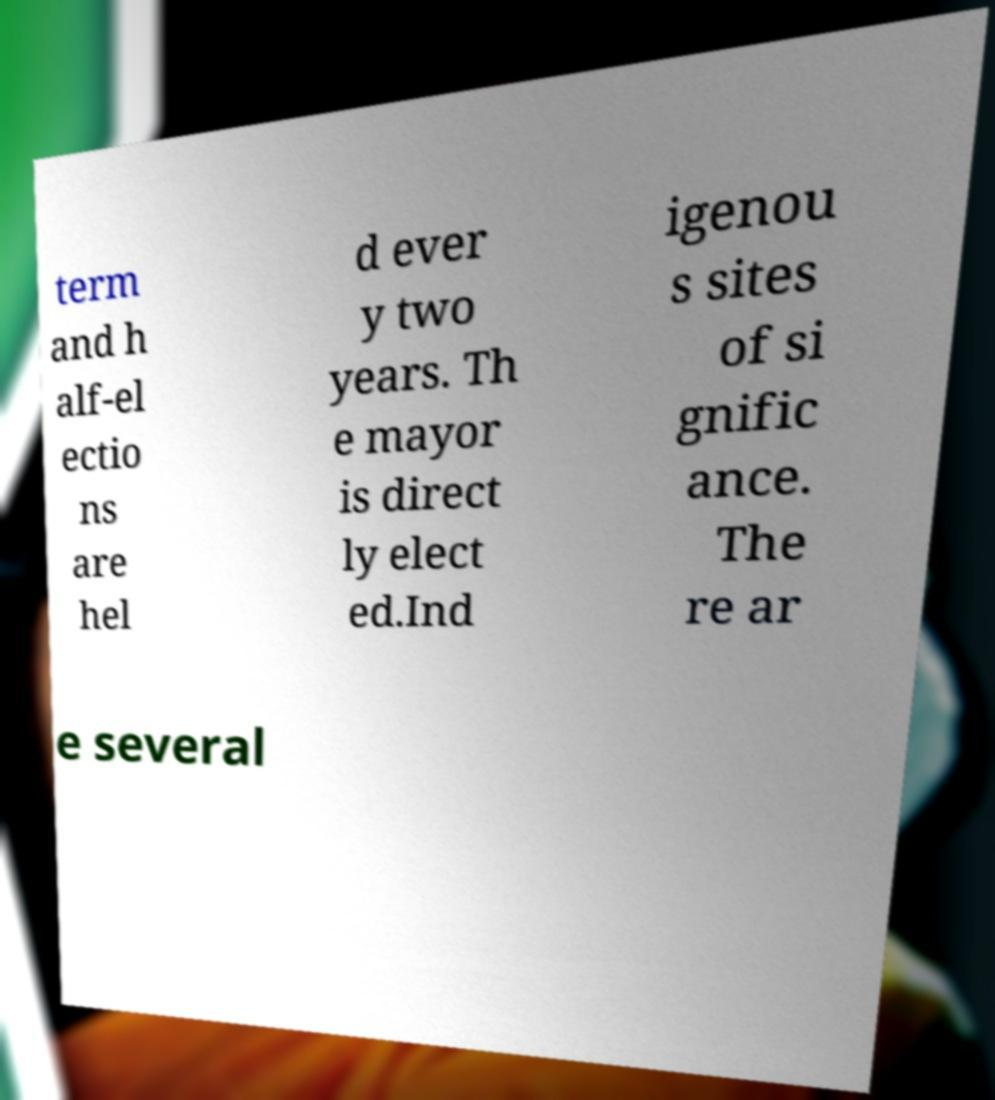Can you accurately transcribe the text from the provided image for me? term and h alf-el ectio ns are hel d ever y two years. Th e mayor is direct ly elect ed.Ind igenou s sites of si gnific ance. The re ar e several 